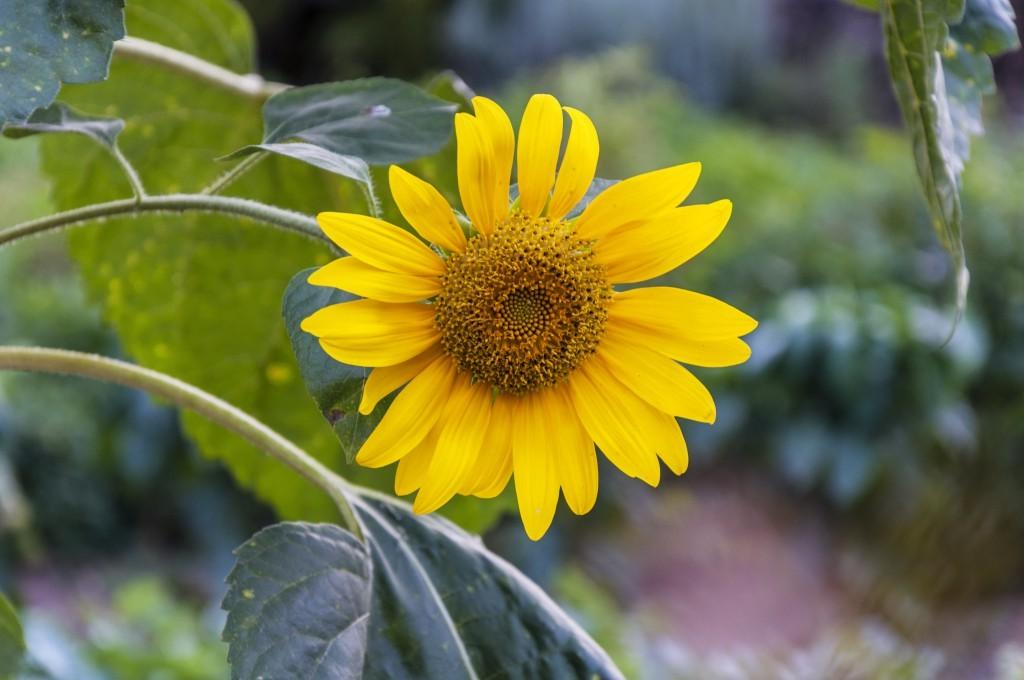What is present in the image? There is a plant in the image. What specific feature can be observed on the plant? The plant has a flower. What is the color of the flower? The flower is in yellow color. What else is part of the plant? The plant has leaves. What can be seen in the background of the image? There are other plants in the background of the image. Where are the background plants located? The background plants are on the land. What type of rhythm does the plant exhibit in the image? The plant does not exhibit any rhythm in the image; it is a static object. 